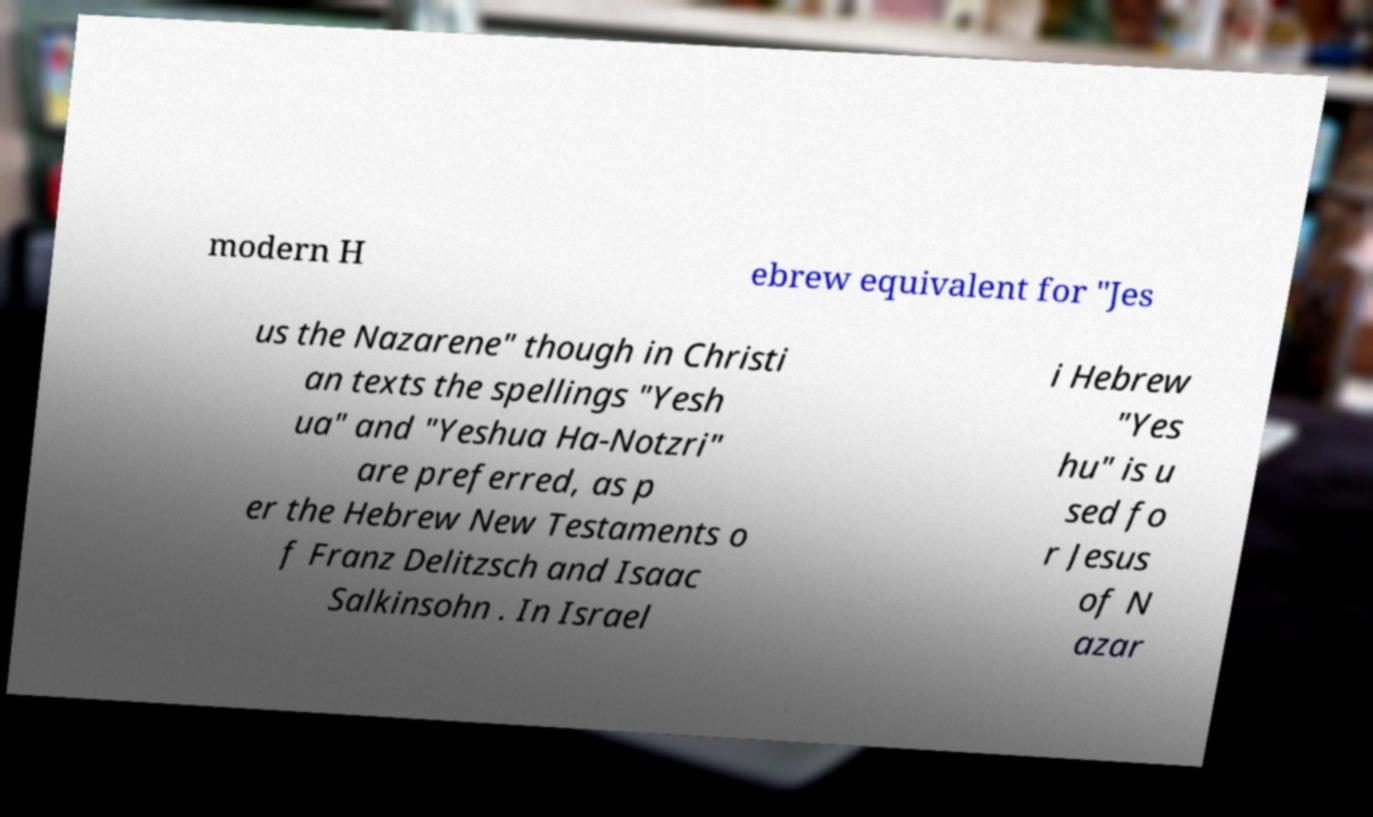Could you assist in decoding the text presented in this image and type it out clearly? modern H ebrew equivalent for "Jes us the Nazarene" though in Christi an texts the spellings "Yesh ua" and "Yeshua Ha-Notzri" are preferred, as p er the Hebrew New Testaments o f Franz Delitzsch and Isaac Salkinsohn . In Israel i Hebrew "Yes hu" is u sed fo r Jesus of N azar 